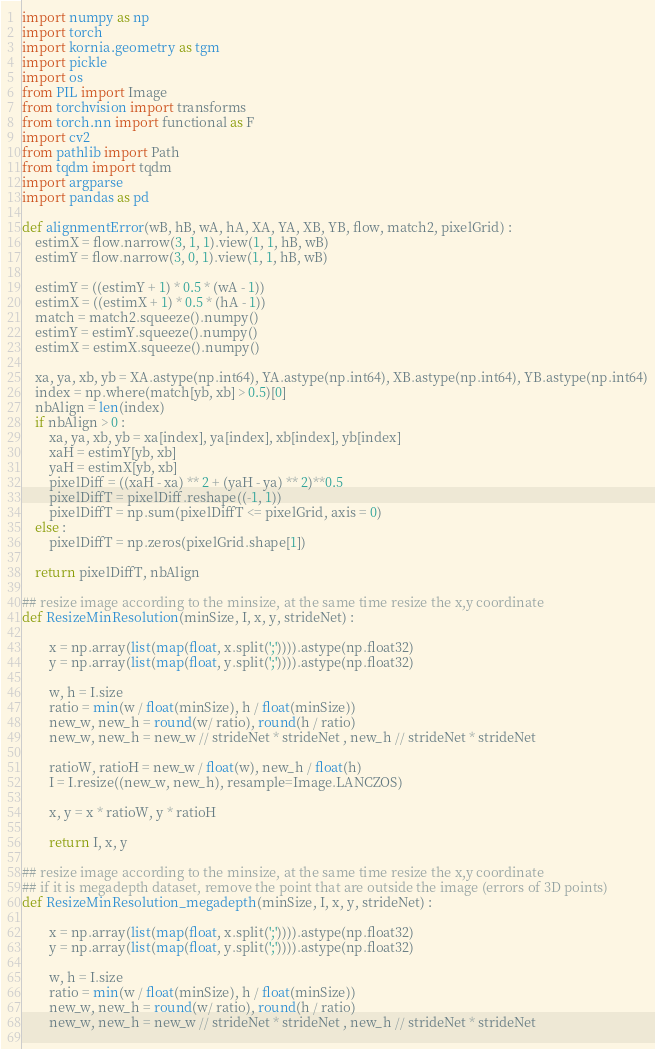Convert code to text. <code><loc_0><loc_0><loc_500><loc_500><_Python_>import numpy as np
import torch
import kornia.geometry as tgm
import pickle
import os
from PIL import Image
from torchvision import transforms
from torch.nn import functional as F
import cv2
from pathlib import Path
from tqdm import tqdm
import argparse 
import pandas as pd 

def alignmentError(wB, hB, wA, hA, XA, YA, XB, YB, flow, match2, pixelGrid) : 
    estimX = flow.narrow(3, 1, 1).view(1, 1, hB, wB)
    estimY = flow.narrow(3, 0, 1).view(1, 1, hB, wB)

    estimY = ((estimY + 1) * 0.5 * (wA - 1))
    estimX = ((estimX + 1) * 0.5 * (hA - 1))
    match = match2.squeeze().numpy()
    estimY = estimY.squeeze().numpy()
    estimX = estimX.squeeze().numpy()
    
    xa, ya, xb, yb = XA.astype(np.int64), YA.astype(np.int64), XB.astype(np.int64), YB.astype(np.int64)
    index = np.where(match[yb, xb] > 0.5)[0]
    nbAlign = len(index)
    if nbAlign > 0 : 
        xa, ya, xb, yb = xa[index], ya[index], xb[index], yb[index]
        xaH = estimY[yb, xb]
        yaH = estimX[yb, xb]
        pixelDiff = ((xaH - xa) ** 2 + (yaH - ya) ** 2)**0.5
        pixelDiffT = pixelDiff.reshape((-1, 1))
        pixelDiffT = np.sum(pixelDiffT <= pixelGrid, axis = 0)
    else : 
        pixelDiffT = np.zeros(pixelGrid.shape[1])
    
    return pixelDiffT, nbAlign

## resize image according to the minsize, at the same time resize the x,y coordinate
def ResizeMinResolution(minSize, I, x, y, strideNet) : 

        x = np.array(list(map(float, x.split(';')))).astype(np.float32)
        y = np.array(list(map(float, y.split(';')))).astype(np.float32)
        
        w, h = I.size
        ratio = min(w / float(minSize), h / float(minSize)) 
        new_w, new_h = round(w/ ratio), round(h / ratio) 
        new_w, new_h = new_w // strideNet * strideNet , new_h // strideNet * strideNet
        
        ratioW, ratioH = new_w / float(w), new_h / float(h)
        I = I.resize((new_w, new_h), resample=Image.LANCZOS)
        
        x, y = x * ratioW, y * ratioH
        
        return I, x, y

## resize image according to the minsize, at the same time resize the x,y coordinate
## if it is megadepth dataset, remove the point that are outside the image (errors of 3D points)
def ResizeMinResolution_megadepth(minSize, I, x, y, strideNet) : 

        x = np.array(list(map(float, x.split(';')))).astype(np.float32)
        y = np.array(list(map(float, y.split(';')))).astype(np.float32)
        
        w, h = I.size
        ratio = min(w / float(minSize), h / float(minSize)) 
        new_w, new_h = round(w/ ratio), round(h / ratio) 
        new_w, new_h = new_w // strideNet * strideNet , new_h // strideNet * strideNet
        </code> 